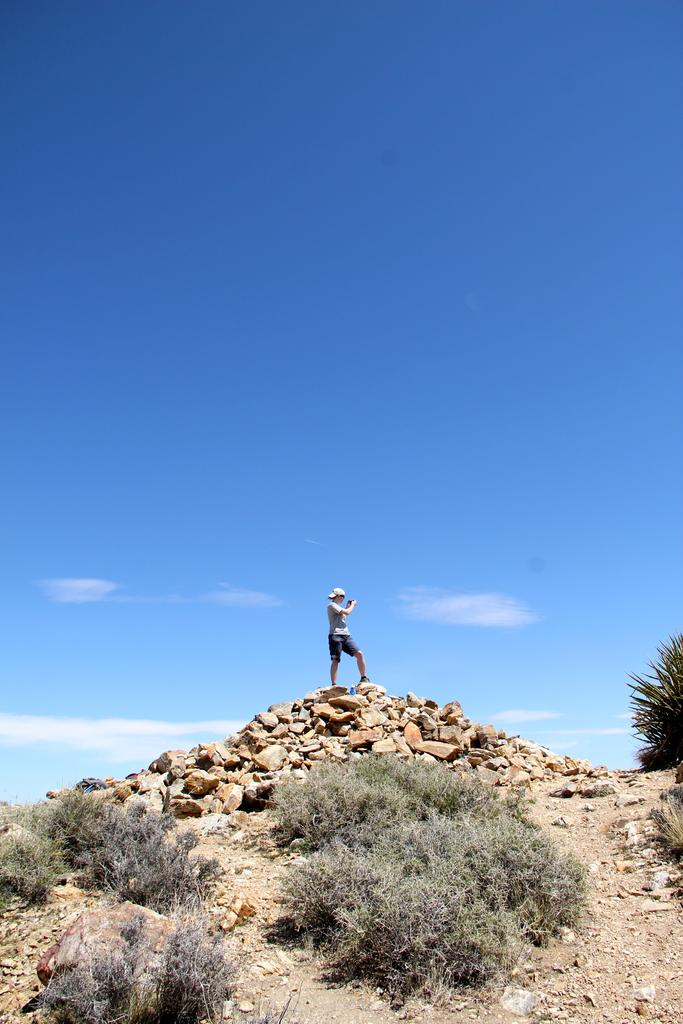What is the person in the image doing? The person is standing on the rocks in the image. What can be seen at the bottom of the image? There are plants at the bottom of the image. What is visible in the background of the image? The sky is visible in the background of the image. What is the smell of the governor in the image? There is no governor present in the image, and therefore no smell can be associated with one. 